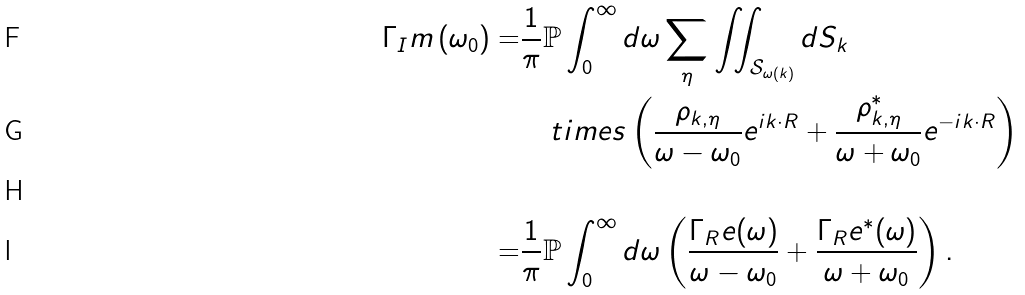Convert formula to latex. <formula><loc_0><loc_0><loc_500><loc_500>\Gamma _ { I } m \left ( \omega _ { 0 } \right ) = & \frac { 1 } { \pi } \mathbb { P } \int _ { 0 } ^ { \infty } d \omega \sum _ { \eta } \iint _ { \mathcal { S } _ { \omega ( k ) } } d S _ { k } \\ & \ \ \ t i m e s \left ( \frac { \rho _ { k , \eta } } { \omega - \omega _ { 0 } } e ^ { i k \cdot R } + \frac { \rho _ { k , \eta } ^ { \ast } } { \omega + \omega _ { 0 } } e ^ { - i k \cdot R } \right ) \\ \\ = & \frac { 1 } { \pi } \mathbb { P } \int _ { 0 } ^ { \infty } d \omega \left ( \frac { \Gamma _ { R } e ( \omega ) } { \omega - \omega _ { 0 } } + \frac { \Gamma _ { R } e ^ { \ast } ( \omega ) } { \omega + \omega _ { 0 } } \right ) .</formula> 